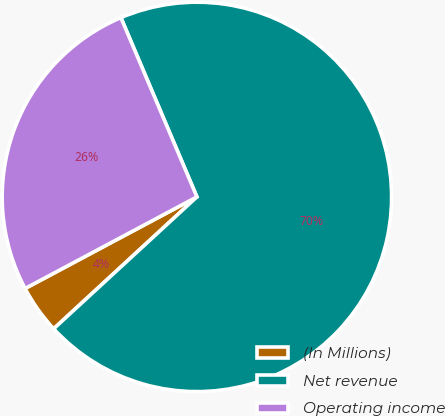Convert chart to OTSL. <chart><loc_0><loc_0><loc_500><loc_500><pie_chart><fcel>(In Millions)<fcel>Net revenue<fcel>Operating income<nl><fcel>4.05%<fcel>69.53%<fcel>26.41%<nl></chart> 